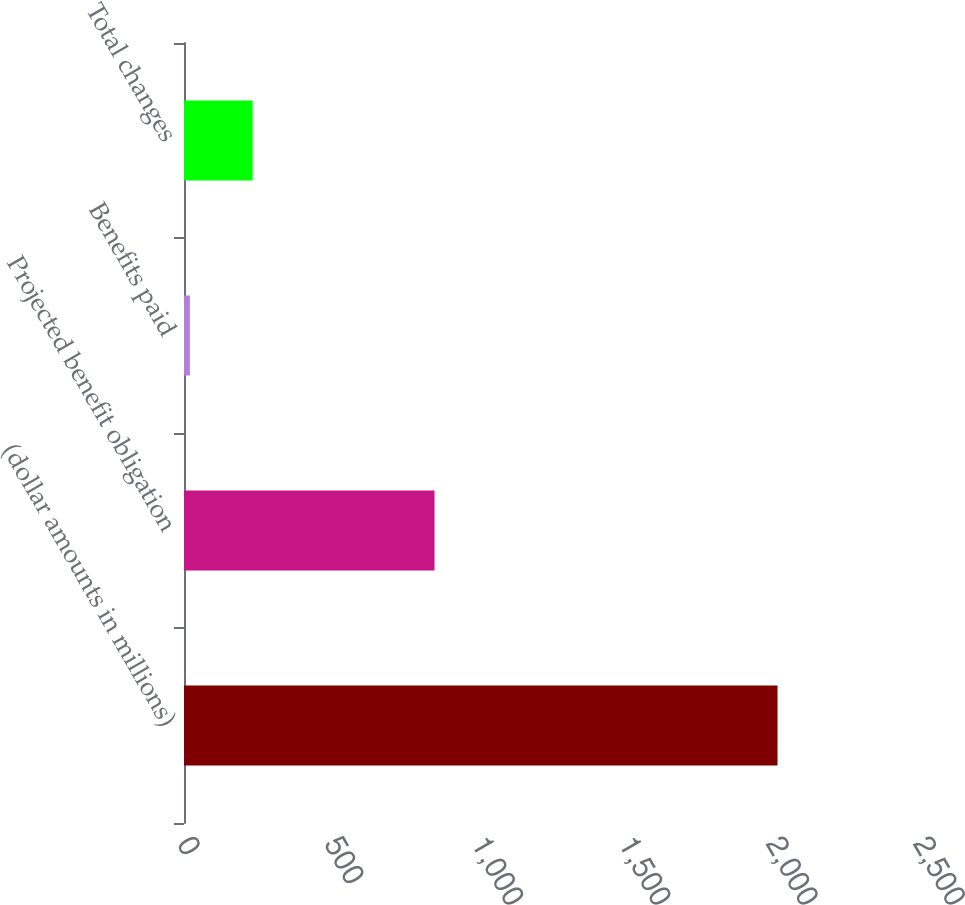<chart> <loc_0><loc_0><loc_500><loc_500><bar_chart><fcel>(dollar amounts in millions)<fcel>Projected benefit obligation<fcel>Benefits paid<fcel>Total changes<nl><fcel>2016<fcel>851<fcel>20<fcel>233<nl></chart> 